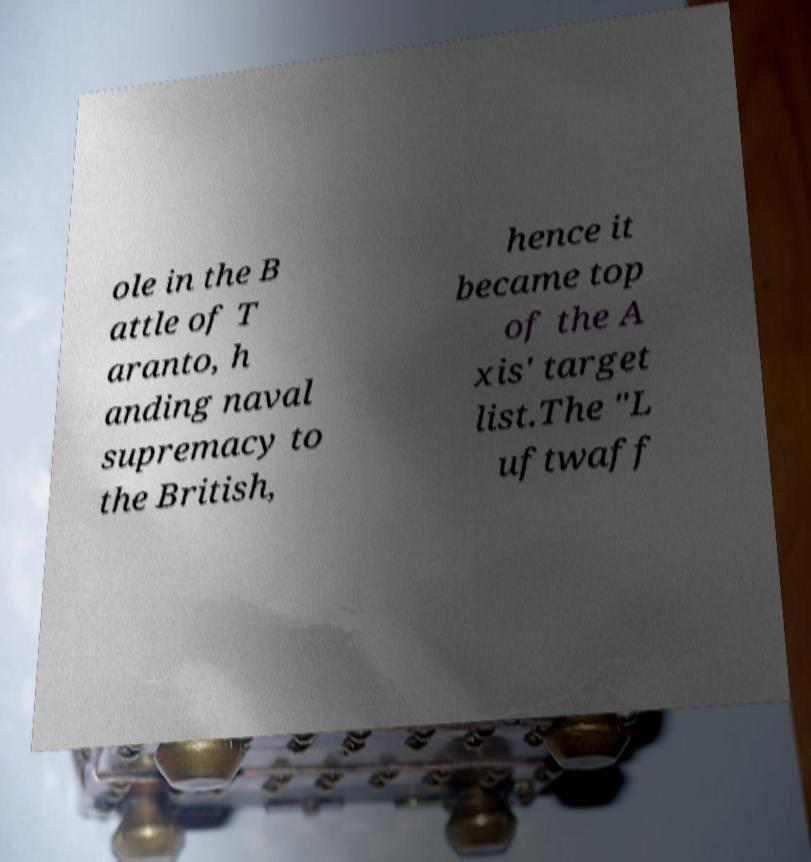Please identify and transcribe the text found in this image. ole in the B attle of T aranto, h anding naval supremacy to the British, hence it became top of the A xis' target list.The "L uftwaff 